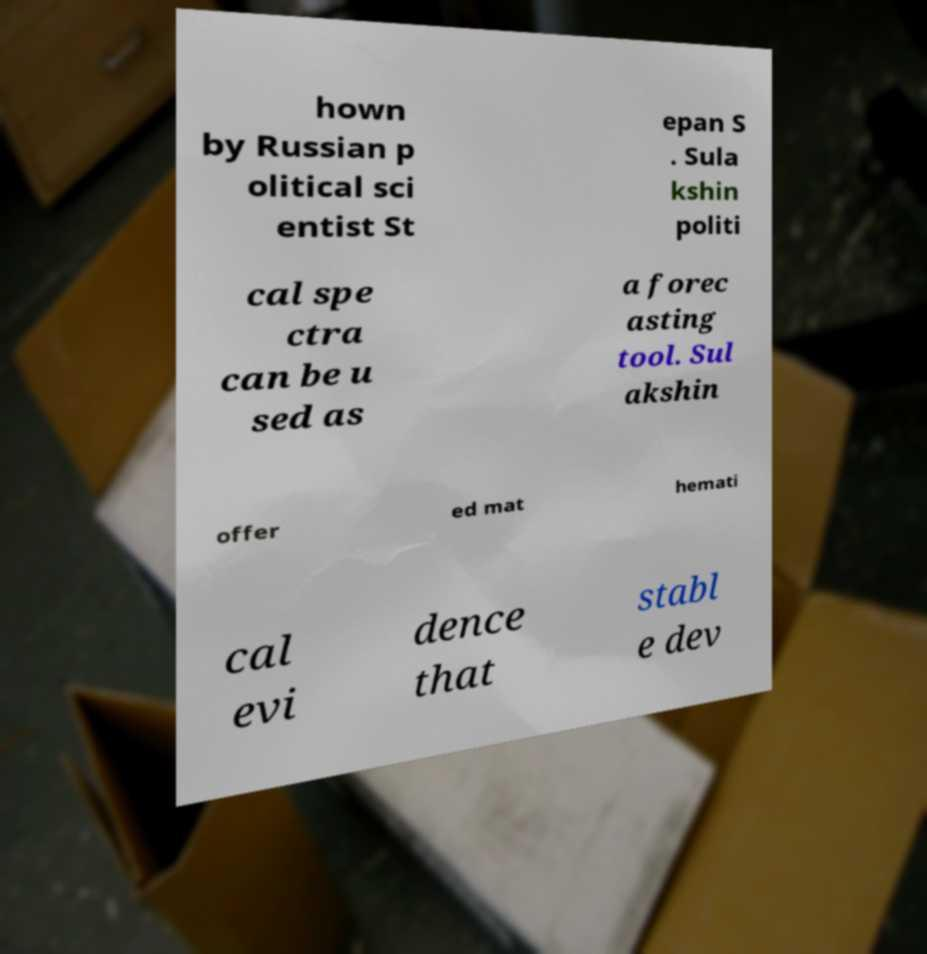Please identify and transcribe the text found in this image. hown by Russian p olitical sci entist St epan S . Sula kshin politi cal spe ctra can be u sed as a forec asting tool. Sul akshin offer ed mat hemati cal evi dence that stabl e dev 